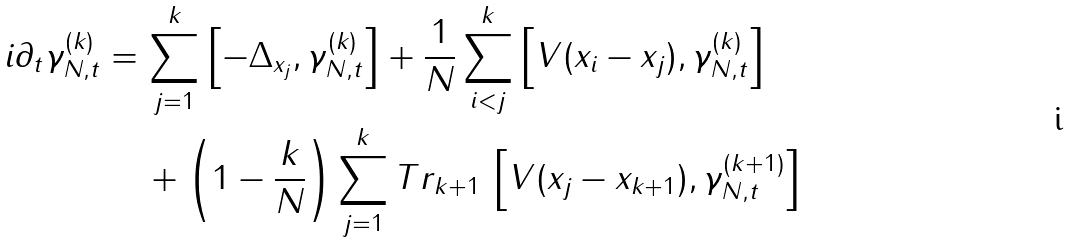<formula> <loc_0><loc_0><loc_500><loc_500>i \partial _ { t } \gamma ^ { ( k ) } _ { N , t } = \, & \sum _ { j = 1 } ^ { k } \left [ - \Delta _ { x _ { j } } , \gamma ^ { ( k ) } _ { N , t } \right ] + \frac { 1 } { N } \sum _ { i < j } ^ { k } \left [ V ( x _ { i } - x _ { j } ) , \gamma ^ { ( k ) } _ { N , t } \right ] \\ & + \left ( 1 - \frac { k } { N } \right ) \sum _ { j = 1 } ^ { k } T r _ { k + 1 } \, \left [ V ( x _ { j } - x _ { k + 1 } ) , \gamma ^ { ( k + 1 ) } _ { N , t } \right ]</formula> 